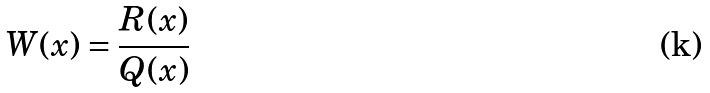Convert formula to latex. <formula><loc_0><loc_0><loc_500><loc_500>W ( x ) = \frac { R ( x ) } { Q ( x ) }</formula> 